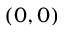Convert formula to latex. <formula><loc_0><loc_0><loc_500><loc_500>( 0 , 0 )</formula> 